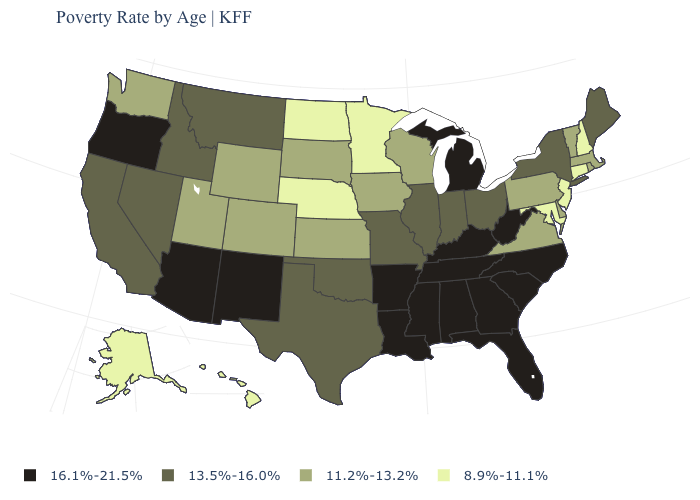What is the lowest value in states that border Florida?
Short answer required. 16.1%-21.5%. What is the value of Kansas?
Answer briefly. 11.2%-13.2%. What is the value of New York?
Keep it brief. 13.5%-16.0%. Name the states that have a value in the range 11.2%-13.2%?
Give a very brief answer. Colorado, Delaware, Iowa, Kansas, Massachusetts, Pennsylvania, Rhode Island, South Dakota, Utah, Vermont, Virginia, Washington, Wisconsin, Wyoming. Does Arkansas have the same value as Wyoming?
Concise answer only. No. What is the value of Tennessee?
Be succinct. 16.1%-21.5%. Does the map have missing data?
Short answer required. No. Name the states that have a value in the range 16.1%-21.5%?
Write a very short answer. Alabama, Arizona, Arkansas, Florida, Georgia, Kentucky, Louisiana, Michigan, Mississippi, New Mexico, North Carolina, Oregon, South Carolina, Tennessee, West Virginia. What is the value of Nebraska?
Quick response, please. 8.9%-11.1%. Does Ohio have the same value as Oklahoma?
Be succinct. Yes. Name the states that have a value in the range 8.9%-11.1%?
Give a very brief answer. Alaska, Connecticut, Hawaii, Maryland, Minnesota, Nebraska, New Hampshire, New Jersey, North Dakota. What is the value of Hawaii?
Give a very brief answer. 8.9%-11.1%. Does Nebraska have the highest value in the USA?
Short answer required. No. Among the states that border Arkansas , does Oklahoma have the lowest value?
Quick response, please. Yes. 